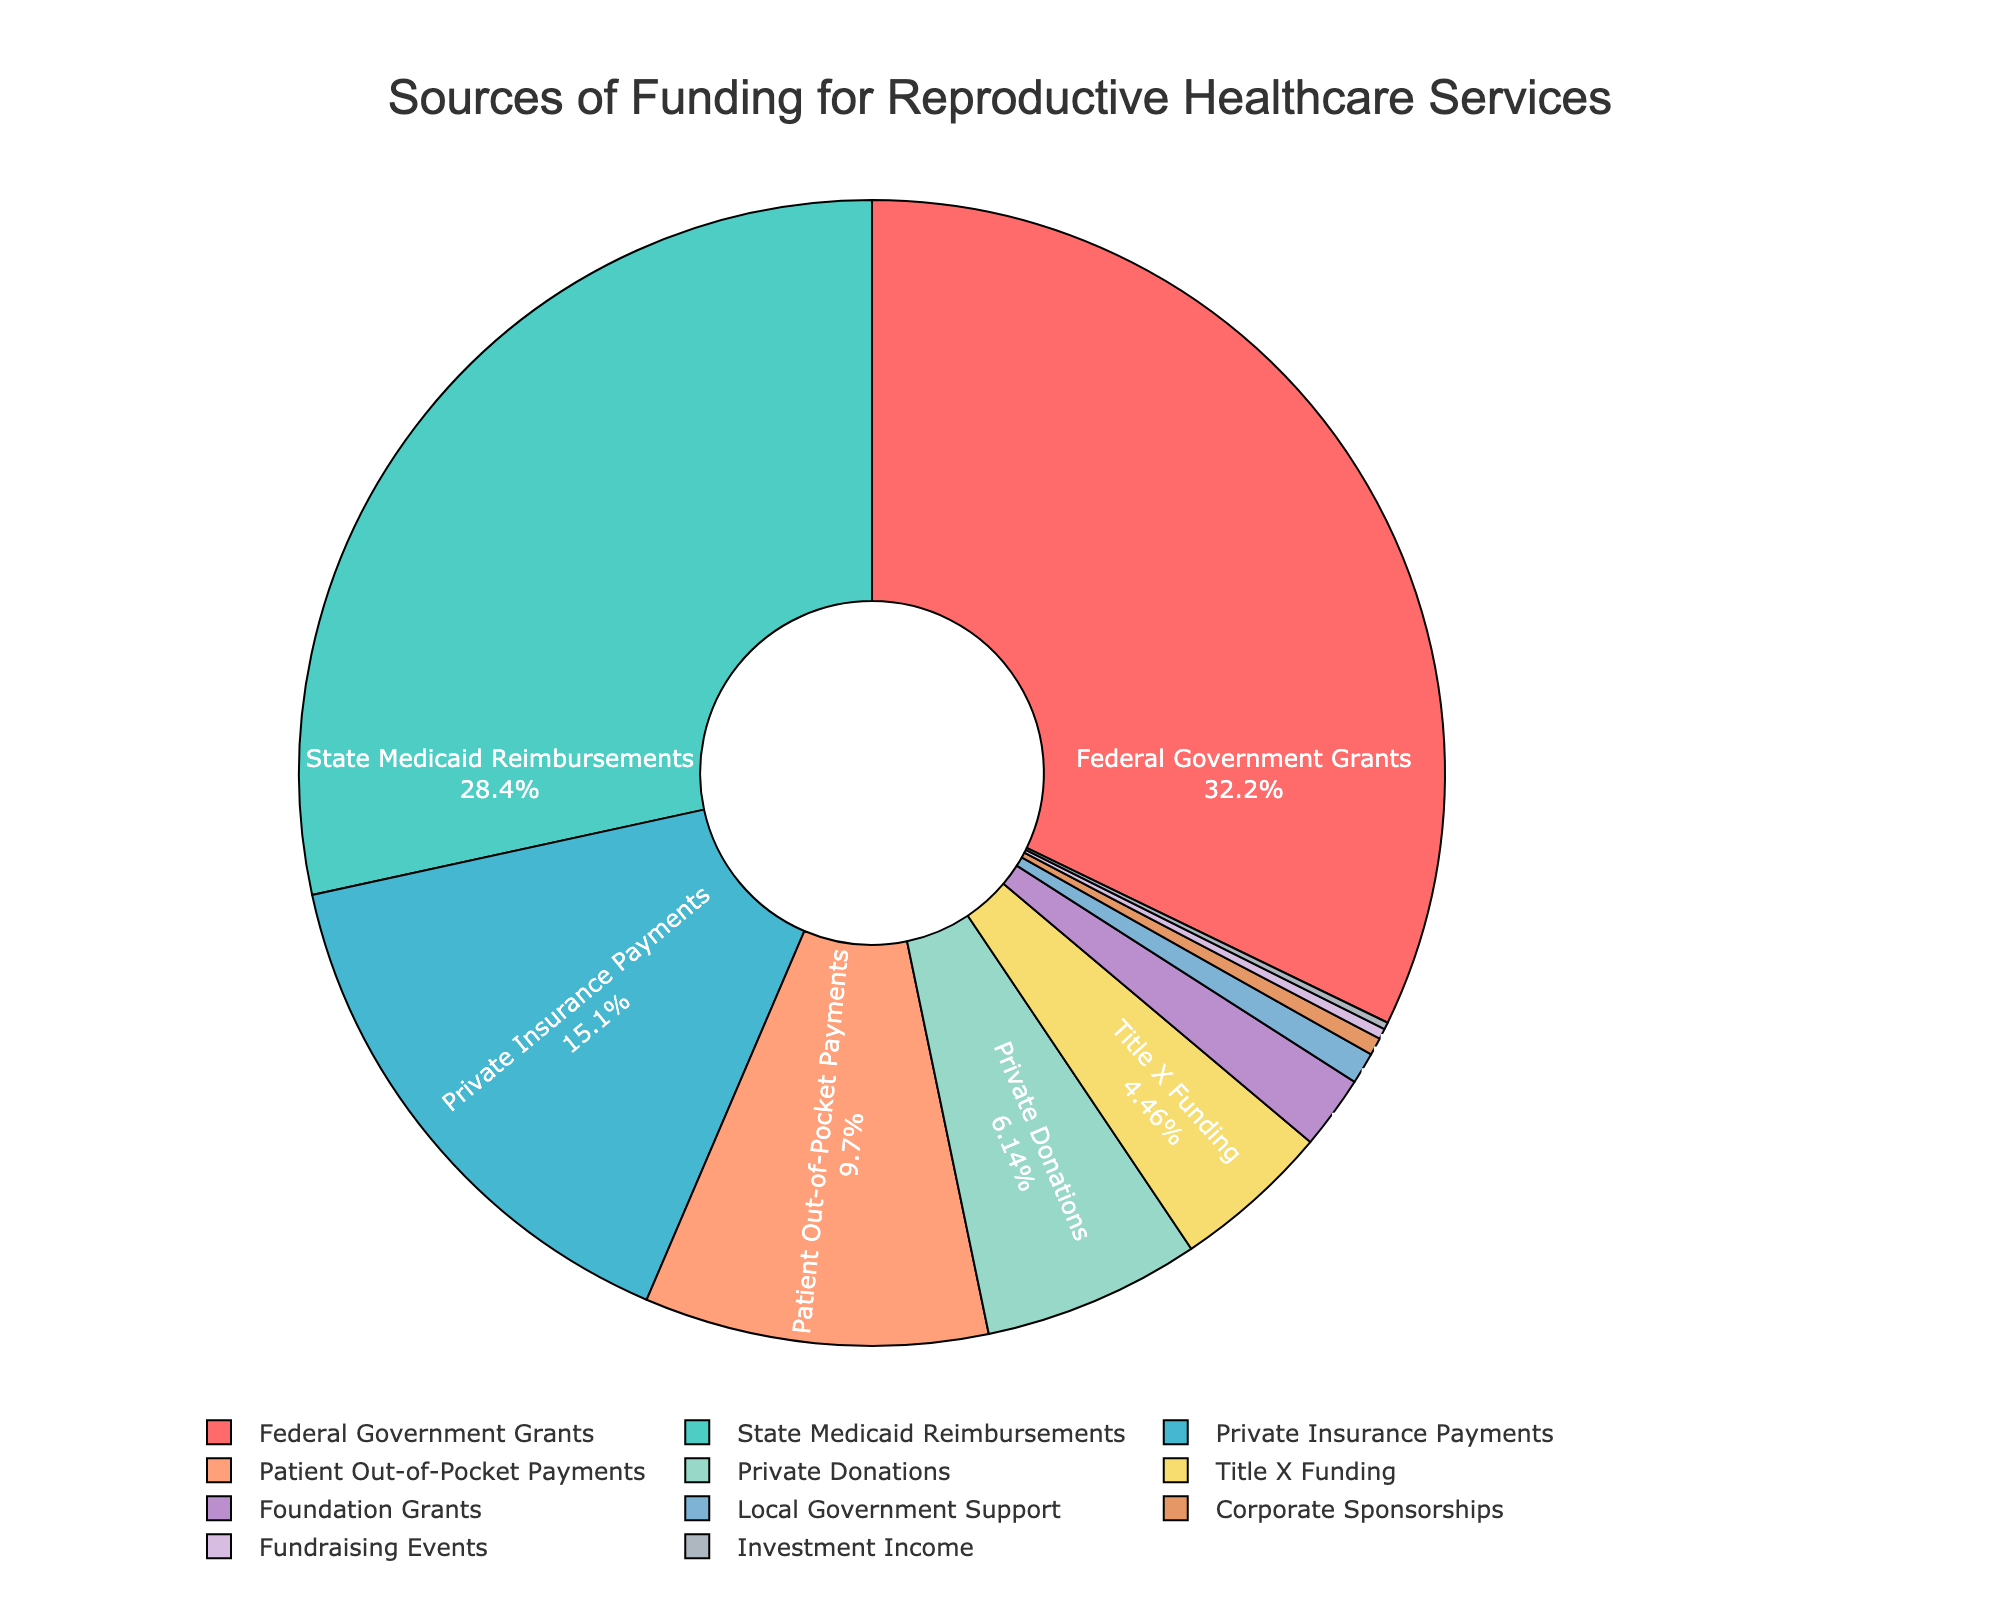In which category does the largest source of funding fall? The pie chart indicates that the largest slice represents the Federal Government Grants. You can tell this easily as it occupies the largest proportion by area compared to other sources.
Answer: Federal Government Grants Which two funding sources combined contribute the most significant percentage? To find the top two sources, we look at the largest and the second-largest slices of the pie chart. The Federal Government Grants (32.5%) and State Medicaid Reimbursements (28.7%) are the largest slices. Combined, they contribute 32.5% + 28.7% = 61.2%.
Answer: Federal Government Grants and State Medicaid Reimbursements What percentage of funding comes from private sources (sum of Private Insurance Payments, Private Donations, and Corporate Sponsorships)? Adding up the slices for Private Insurance Payments (15.3%), Private Donations (6.2%), and Corporate Sponsorships (0.5%) gives us 15.3% + 6.2% + 0.5% = 22%.
Answer: 22% How much larger is the funding from State Medicaid Reimbursements compared to Patient Out-of-Pocket Payments? Subtract the percentage of Patient Out-of-Pocket Payments (9.8%) from State Medicaid Reimbursements (28.7%). The difference is 28.7% - 9.8% = 18.9%.
Answer: 18.9% Which funding source is smallest, and how does its percentage compare to the largest source? The smallest source is Investment Income at 0.2%. Comparing this to the largest source, Federal Government Grants at 32.5%, by division, 32.5% / 0.2% = 162.5. So, the Federal Government Grants percentage is 162.5 times larger.
Answer: Investment Income, Federal Government Grants' percentage is 162.5 times larger What proportion of funding is accounted for by Title X Funding and Foundation Grants combined? Adding the percentages from Title X Funding (4.5%) and Foundation Grants (2.1%) gives 4.5% + 2.1% = 6.6%.
Answer: 6.6% Is the funding from Private Insurance Payments greater or less than the sum of Title X Funding and Foundation Grants? The funding from Private Insurance Payments is 15.3%. The sum of Title X Funding (4.5%) and Foundation Grants (2.1%) is 4.5% + 2.1% = 6.6%. The funding from Private Insurance Payments is greater.
Answer: Greater Which funding source is represented by the color green, and what is its percentage? From the color code list provided, green represents State Medicaid Reimbursements. By looking at the slice in the chart that corresponds to green, we see it accounts for 28.7%.
Answer: State Medicaid Reimbursements, 28.7% What is the total percentage contributed by governmental sources (Federal Government Grants, State Medicaid Reimbursements, Title X Funding, and Local Government Support)? Adding the percentages from Federal Government Grants (32.5%), State Medicaid Reimbursements (28.7%), Title X Funding (4.5%), and Local Government Support (0.9%) gives us 32.5% + 28.7% + 4.5% + 0.9% = 66.6%.
Answer: 66.6% 